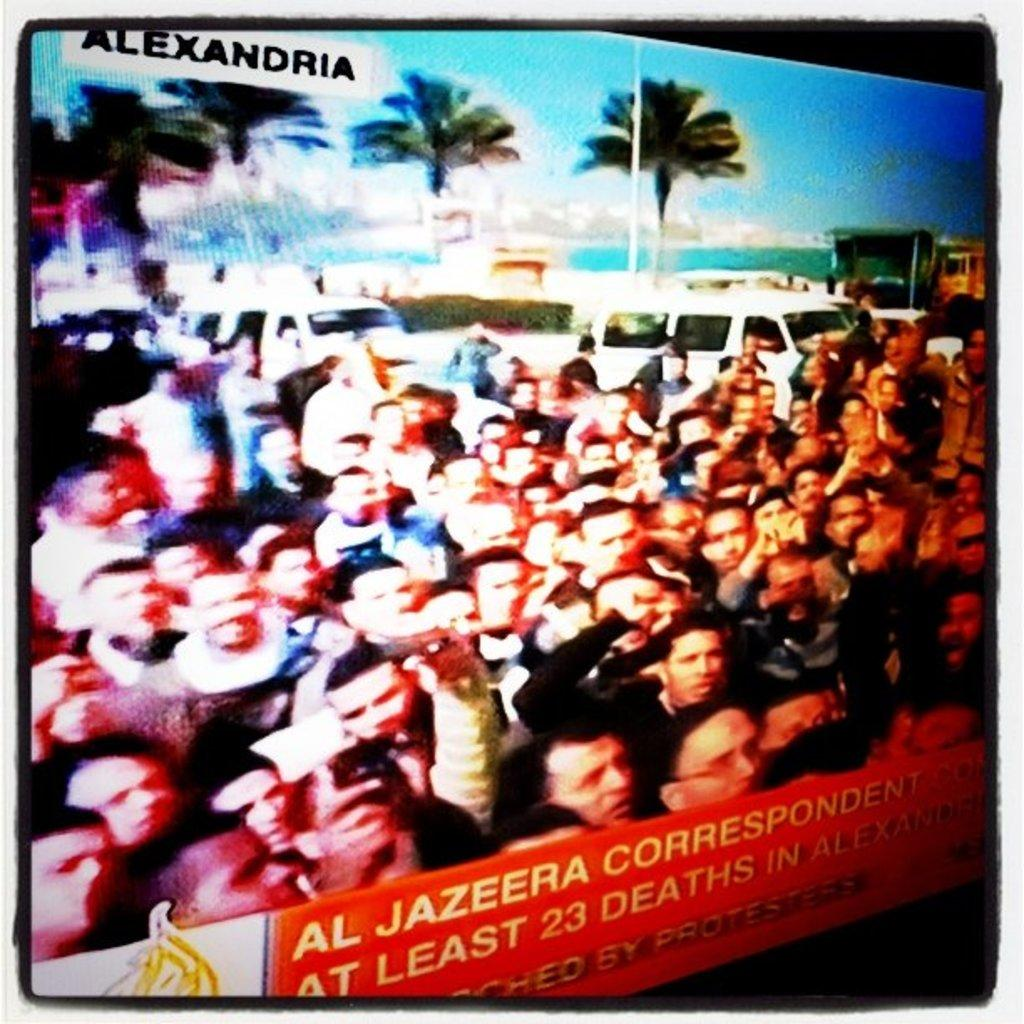<image>
Summarize the visual content of the image. tv screen showing crowd of people in front of white vans and at bottom of screen it tells of at least 23 deaths 